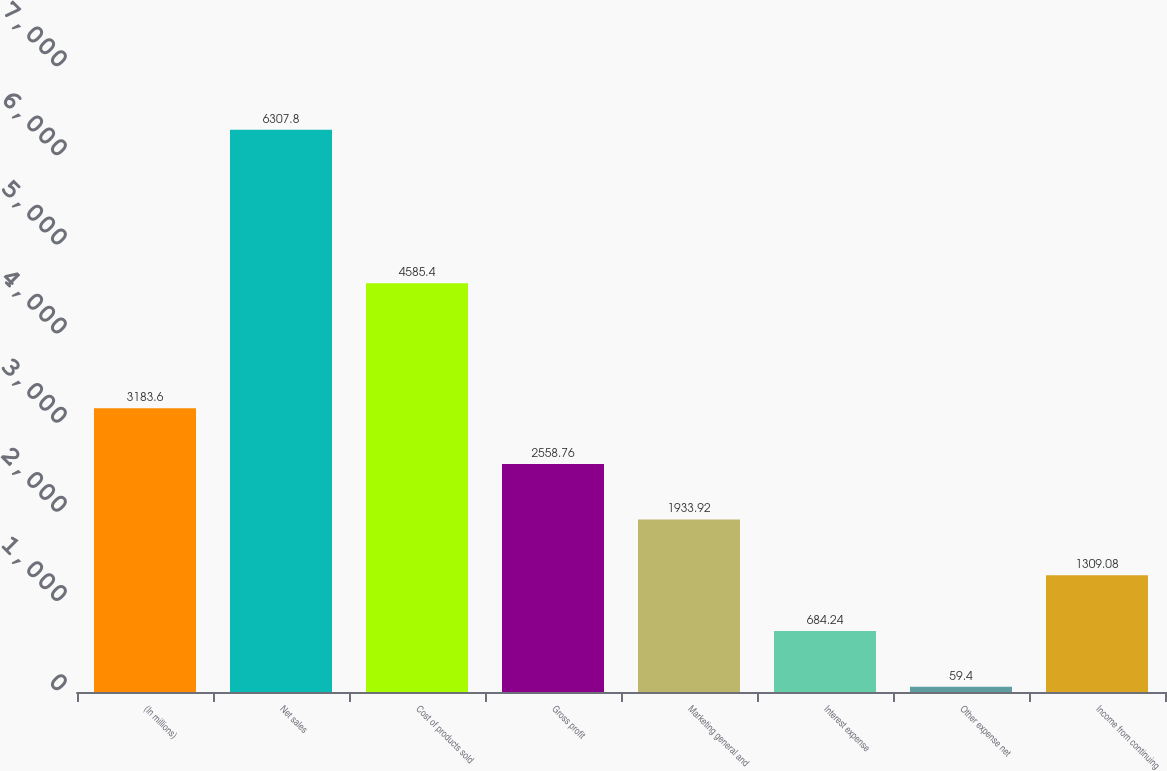<chart> <loc_0><loc_0><loc_500><loc_500><bar_chart><fcel>(In millions)<fcel>Net sales<fcel>Cost of products sold<fcel>Gross profit<fcel>Marketing general and<fcel>Interest expense<fcel>Other expense net<fcel>Income from continuing<nl><fcel>3183.6<fcel>6307.8<fcel>4585.4<fcel>2558.76<fcel>1933.92<fcel>684.24<fcel>59.4<fcel>1309.08<nl></chart> 